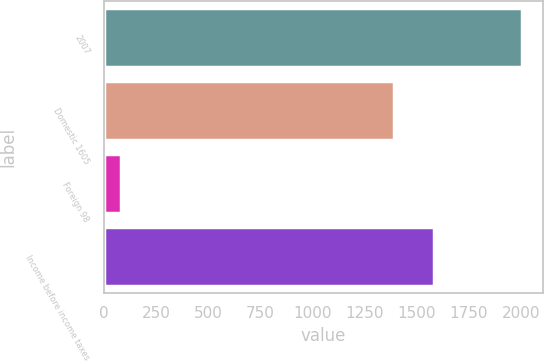Convert chart to OTSL. <chart><loc_0><loc_0><loc_500><loc_500><bar_chart><fcel>2007<fcel>Domestic 1605<fcel>Foreign 98<fcel>Income before income taxes<nl><fcel>2006<fcel>1390<fcel>84<fcel>1582.2<nl></chart> 